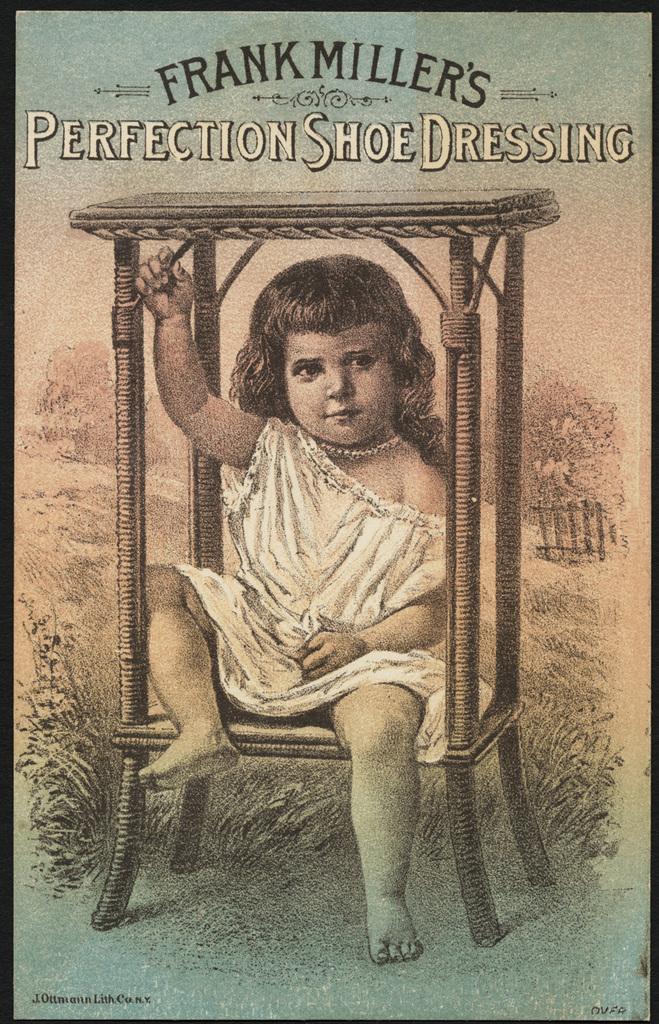What man's name is shown?
Make the answer very short. Frank miller. What type of shoe dressing?
Make the answer very short. Perfection. 